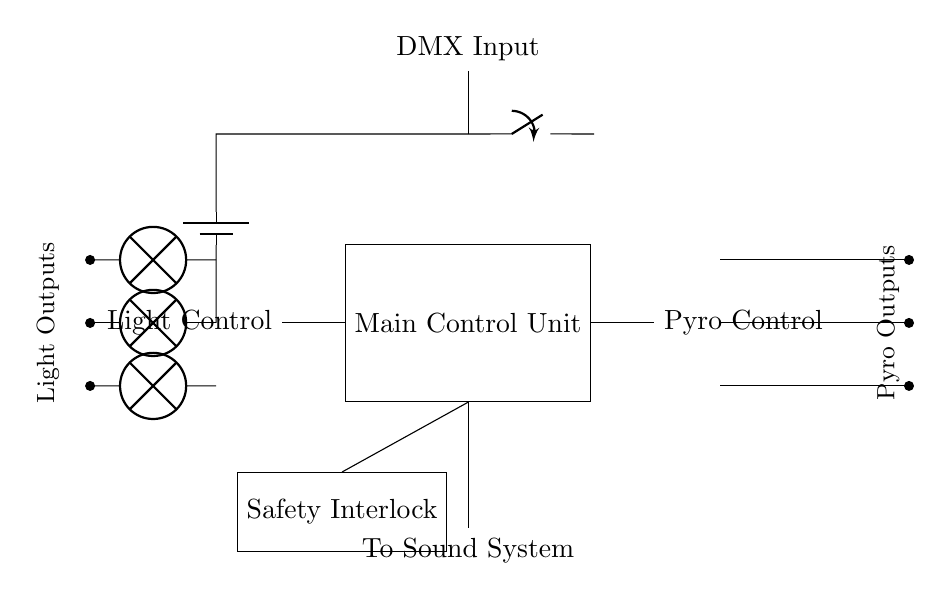What is the main component in this circuit? The main component shown is labeled as the "Main Control Unit," which is central to the operation of the circuit.
Answer: Main Control Unit How many channels are dedicated to pyrotechnics control? There are three separate control channels for pyrotechnics indicated by the PMOS components connected to the control unit.
Answer: Three What does the safety interlock control? The Safety Interlock acts as a protective measure to ensure safe operation, as it is connected to the Main Control Unit and prevents unauthorized activation of the circuit.
Answer: Safety Where is the DMX input located? The DMX Input is positioned at the top of the circuit, leading directly down to the Main Control Unit, indicating that it receives external control signals.
Answer: Top What is the function of the components labeled as lamps? The lamp components are used for the light control output, triggering specific lighting effects during a performance as controlled by the Main Control Unit.
Answer: Light Control How are pyrotechnic outputs indicated in the diagram? The pyrotechnic outputs are represented by the PMOS components, which are directly linked to the Main Control Unit and serve as control interfaces for firing pyrotechnics.
Answer: Outputs Which direction does the current flow from the power supply? The current flows from the battery through the switch and into the Main Control Unit before being distributed to various outputs, indicating a clockwise flow in the circuit.
Answer: Clockwise 